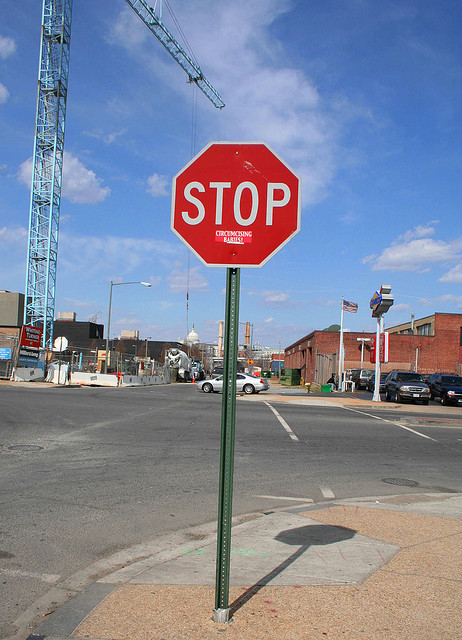Please identify all text content in this image. STOP 